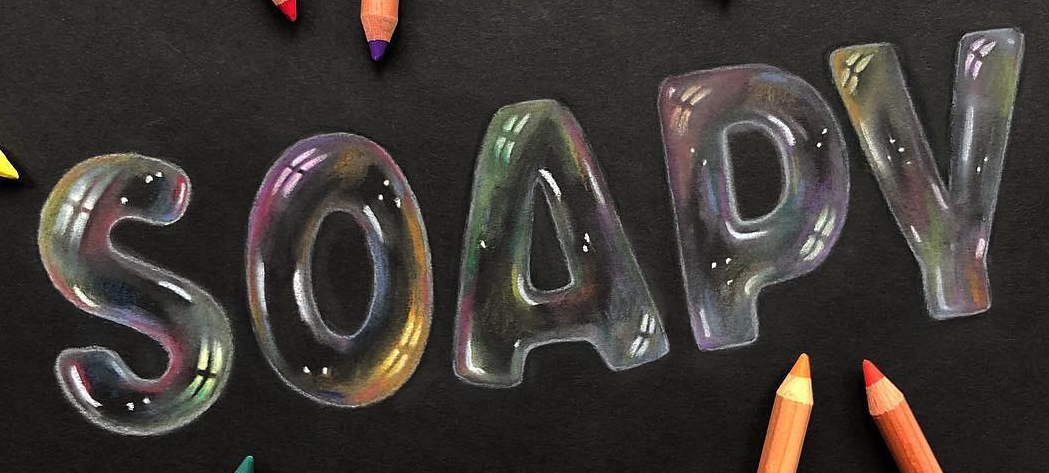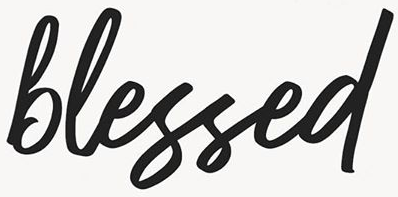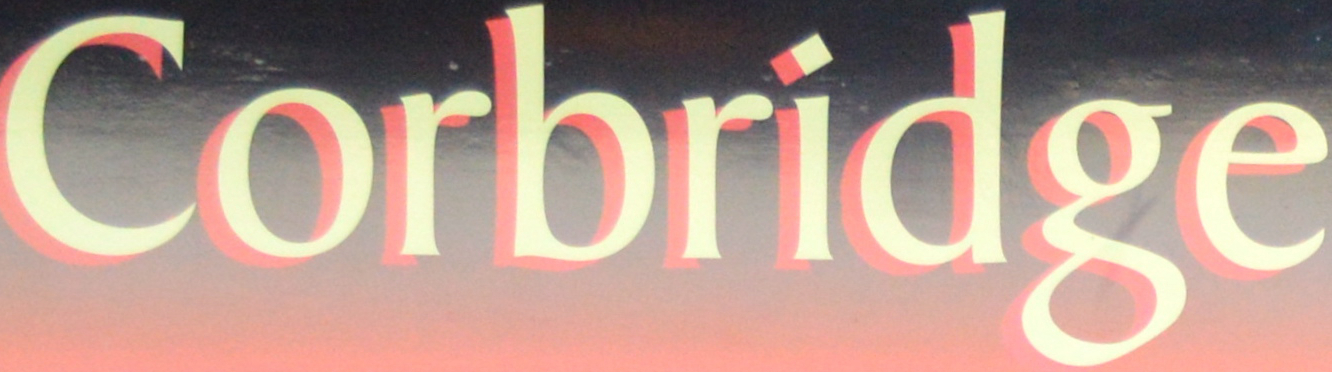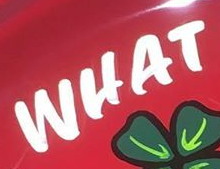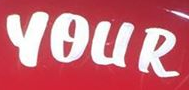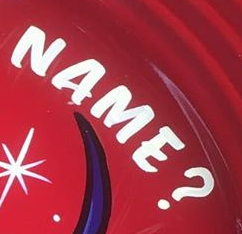What words are shown in these images in order, separated by a semicolon? SOAPY; blessed; Corbridge; WHAT; YOUR; NAME? 